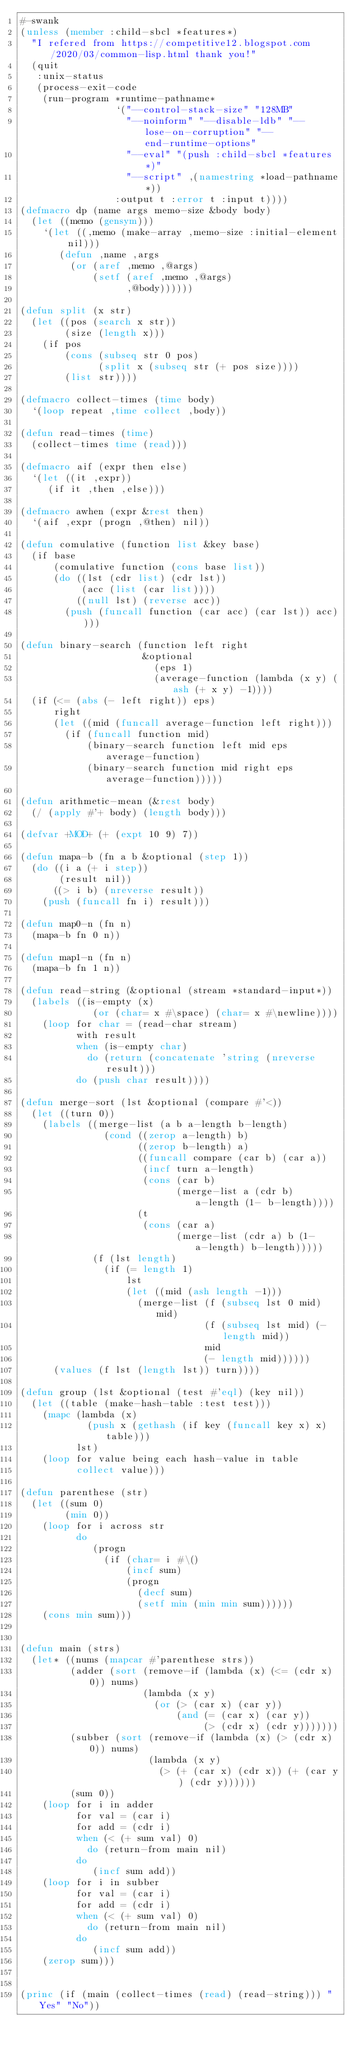<code> <loc_0><loc_0><loc_500><loc_500><_Lisp_>#-swank
(unless (member :child-sbcl *features*)
  "I refered from https://competitive12.blogspot.com/2020/03/common-lisp.html thank you!"
  (quit
   :unix-status
   (process-exit-code
    (run-program *runtime-pathname*
                 `("--control-stack-size" "128MB"
                   "--noinform" "--disable-ldb" "--lose-on-corruption" "--end-runtime-options"
                   "--eval" "(push :child-sbcl *features*)"
                   "--script" ,(namestring *load-pathname*))
                 :output t :error t :input t))))
(defmacro dp (name args memo-size &body body)
  (let ((memo (gensym)))
    `(let ((,memo (make-array ,memo-size :initial-element nil)))
       (defun ,name ,args
         (or (aref ,memo ,@args)
             (setf (aref ,memo ,@args)
                   ,@body))))))

(defun split (x str)
  (let ((pos (search x str))
        (size (length x)))
    (if pos
        (cons (subseq str 0 pos)
              (split x (subseq str (+ pos size))))
        (list str))))

(defmacro collect-times (time body)
  `(loop repeat ,time collect ,body))

(defun read-times (time)
  (collect-times time (read)))

(defmacro aif (expr then else)
  `(let ((it ,expr))
     (if it ,then ,else)))

(defmacro awhen (expr &rest then)
  `(aif ,expr (progn ,@then) nil))

(defun comulative (function list &key base)
  (if base
      (comulative function (cons base list))
      (do ((lst (cdr list) (cdr lst))
           (acc (list (car list))))
          ((null lst) (reverse acc))
        (push (funcall function (car acc) (car lst)) acc))))

(defun binary-search (function left right
                      &optional
                        (eps 1)
                        (average-function (lambda (x y) (ash (+ x y) -1))))
  (if (<= (abs (- left right)) eps)
      right
      (let ((mid (funcall average-function left right)))
        (if (funcall function mid)
            (binary-search function left mid eps average-function)
            (binary-search function mid right eps average-function)))))

(defun arithmetic-mean (&rest body)
  (/ (apply #'+ body) (length body)))

(defvar +MOD+ (+ (expt 10 9) 7))

(defun mapa-b (fn a b &optional (step 1))
  (do ((i a (+ i step))
       (result nil))
      ((> i b) (nreverse result))
    (push (funcall fn i) result)))

(defun map0-n (fn n)
  (mapa-b fn 0 n))

(defun map1-n (fn n)
  (mapa-b fn 1 n))

(defun read-string (&optional (stream *standard-input*))
  (labels ((is-empty (x)
             (or (char= x #\space) (char= x #\newline))))
    (loop for char = (read-char stream)
          with result
          when (is-empty char)
            do (return (concatenate 'string (nreverse result)))
          do (push char result))))

(defun merge-sort (lst &optional (compare #'<))
  (let ((turn 0))
    (labels ((merge-list (a b a-length b-length)
               (cond ((zerop a-length) b)
                     ((zerop b-length) a)
                     ((funcall compare (car b) (car a))
                      (incf turn a-length)
                      (cons (car b)
                            (merge-list a (cdr b) a-length (1- b-length))))
                     (t
                      (cons (car a)
                            (merge-list (cdr a) b (1- a-length) b-length)))))
             (f (lst length)
               (if (= length 1)
                   lst
                   (let ((mid (ash length -1)))
                     (merge-list (f (subseq lst 0 mid) mid)
                                 (f (subseq lst mid) (- length mid))
                                 mid
                                 (- length mid))))))
      (values (f lst (length lst)) turn))))

(defun group (lst &optional (test #'eql) (key nil))
  (let ((table (make-hash-table :test test)))
    (mapc (lambda (x)
            (push x (gethash (if key (funcall key x) x) table)))
          lst)
    (loop for value being each hash-value in table
          collect value)))

(defun parenthese (str)
  (let ((sum 0)
        (min 0))
    (loop for i across str
          do
             (progn
               (if (char= i #\()
                   (incf sum)
                   (progn
                     (decf sum)
                     (setf min (min min sum))))))
    (cons min sum)))


(defun main (strs)
  (let* ((nums (mapcar #'parenthese strs))
         (adder (sort (remove-if (lambda (x) (<= (cdr x) 0)) nums)
                      (lambda (x y)
                        (or (> (car x) (car y))
                            (and (= (car x) (car y))
                                 (> (cdr x) (cdr y)))))))
         (subber (sort (remove-if (lambda (x) (> (cdr x) 0)) nums)
                       (lambda (x y)
                         (> (+ (car x) (cdr x)) (+ (car y) (cdr y))))))
         (sum 0))
    (loop for i in adder
          for val = (car i)
          for add = (cdr i)
          when (< (+ sum val) 0)
            do (return-from main nil)
          do
             (incf sum add))
    (loop for i in subber
          for val = (car i)
          for add = (cdr i)
          when (< (+ sum val) 0)
            do (return-from main nil)
          do
             (incf sum add))
    (zerop sum)))


(princ (if (main (collect-times (read) (read-string))) "Yes" "No"))
</code> 